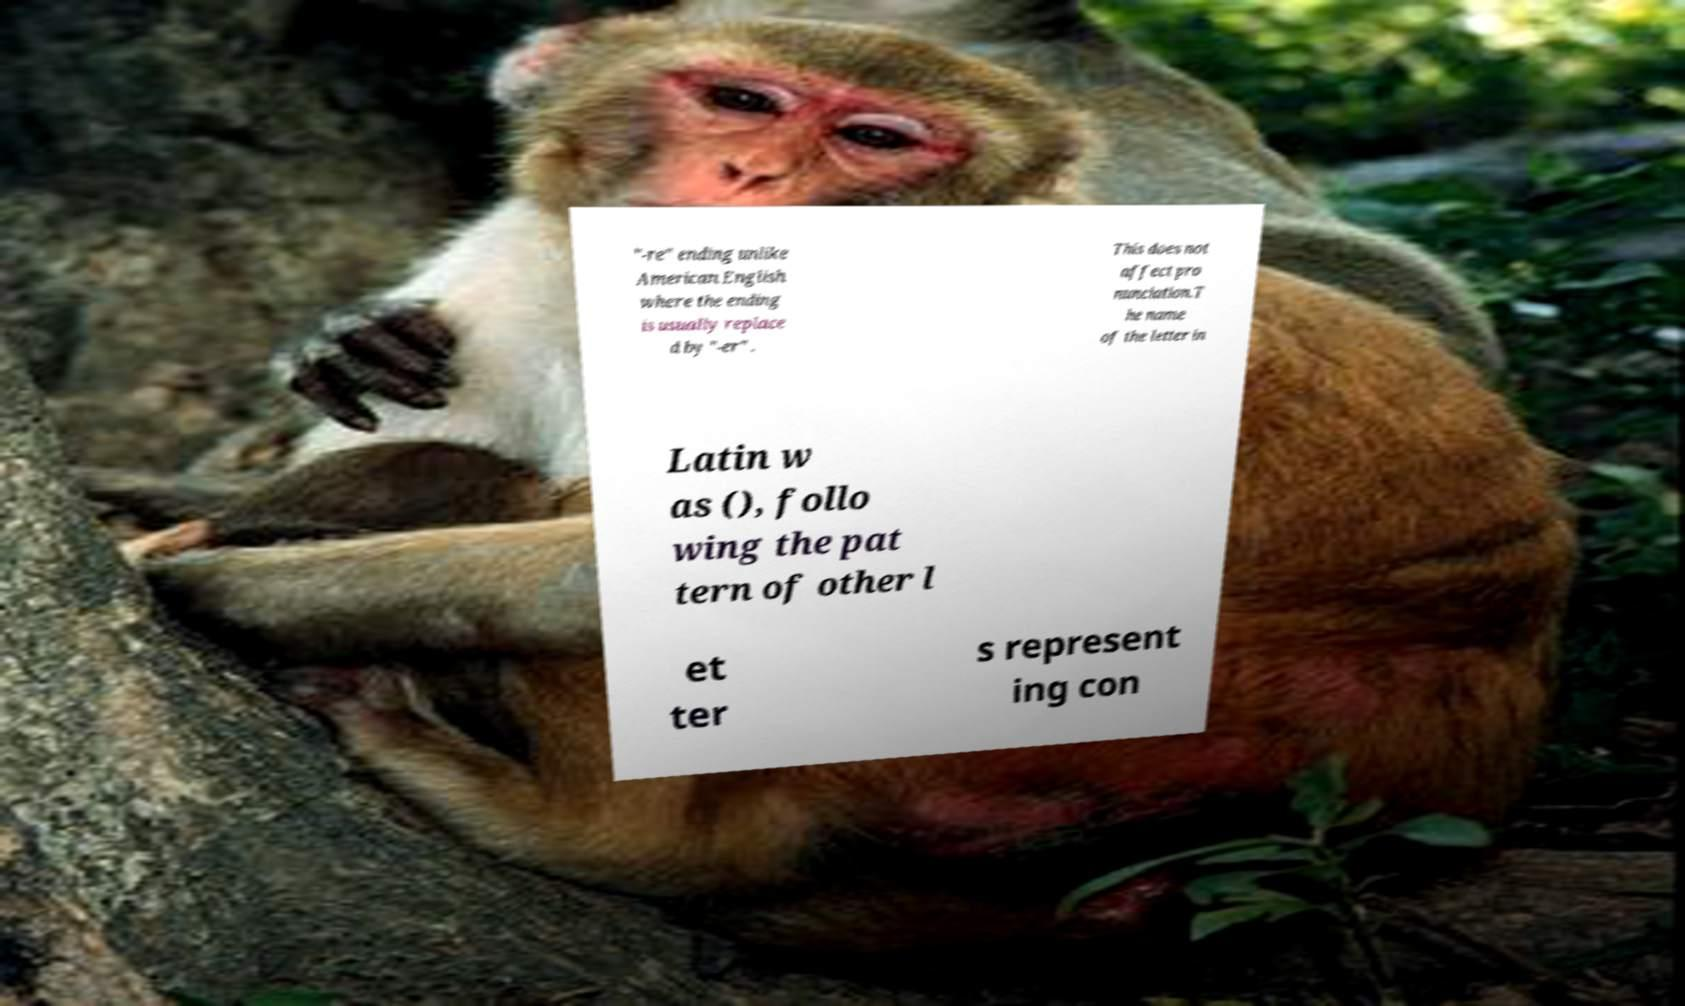Can you accurately transcribe the text from the provided image for me? "-re" ending unlike American English where the ending is usually replace d by "-er" . This does not affect pro nunciation.T he name of the letter in Latin w as (), follo wing the pat tern of other l et ter s represent ing con 